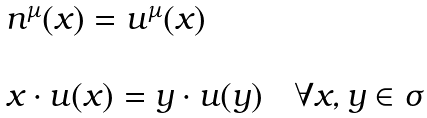Convert formula to latex. <formula><loc_0><loc_0><loc_500><loc_500>\begin{array} { l } n ^ { \mu } ( x ) = u ^ { \mu } ( x ) \\ \\ x \cdot u ( x ) = y \cdot u ( y ) \quad \forall x , y \in \sigma \end{array}</formula> 